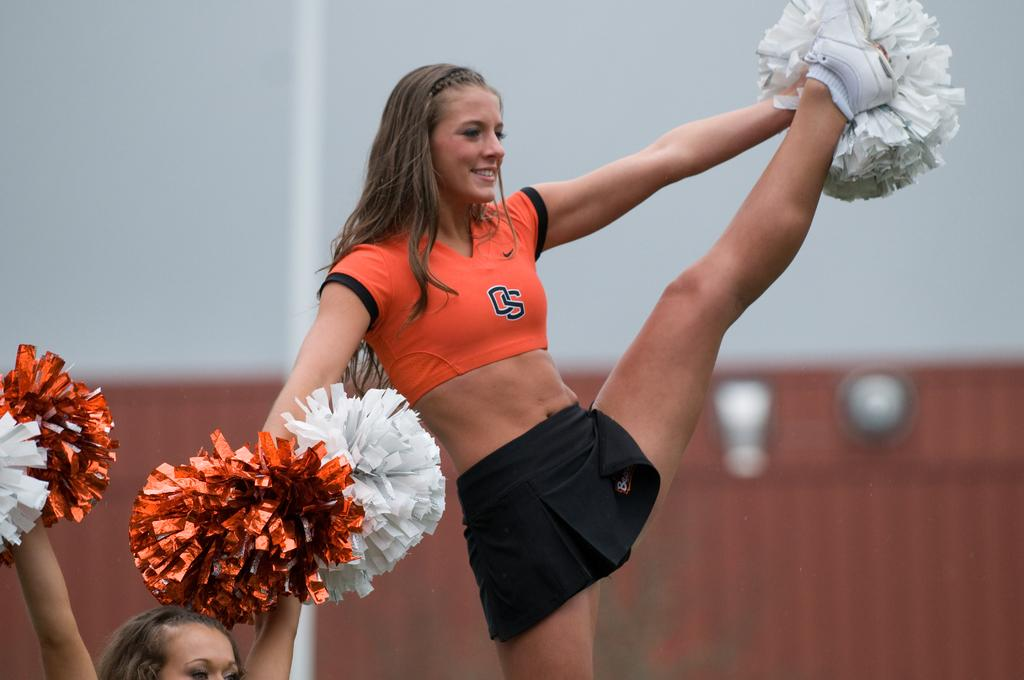<image>
Offer a succinct explanation of the picture presented. A cheerleader with a orange top and the letters OS on it is cheering with a leg up in the air. 